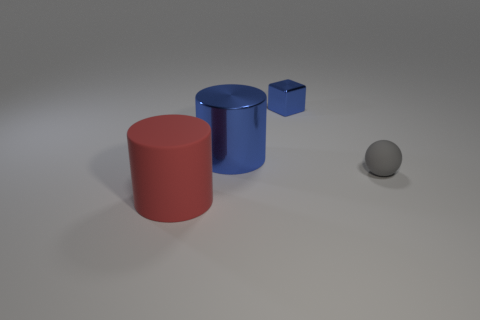There is another thing that is the same color as the small metallic object; what shape is it?
Ensure brevity in your answer.  Cylinder. What is the tiny sphere made of?
Offer a terse response. Rubber. There is another shiny thing that is the same shape as the big red thing; what size is it?
Provide a succinct answer. Large. Is the big matte cylinder the same color as the tiny shiny thing?
Offer a terse response. No. What number of other objects are there of the same material as the big blue cylinder?
Offer a very short reply. 1. Are there an equal number of cubes on the left side of the big red rubber cylinder and big red cylinders?
Ensure brevity in your answer.  No. Do the blue shiny thing that is on the left side of the block and the tiny blue metallic thing have the same size?
Your answer should be very brief. No. How many rubber spheres are on the left side of the gray ball?
Ensure brevity in your answer.  0. What is the thing that is both right of the big blue cylinder and behind the gray sphere made of?
Offer a terse response. Metal. What number of large objects are either blue cylinders or rubber objects?
Your answer should be very brief. 2. 